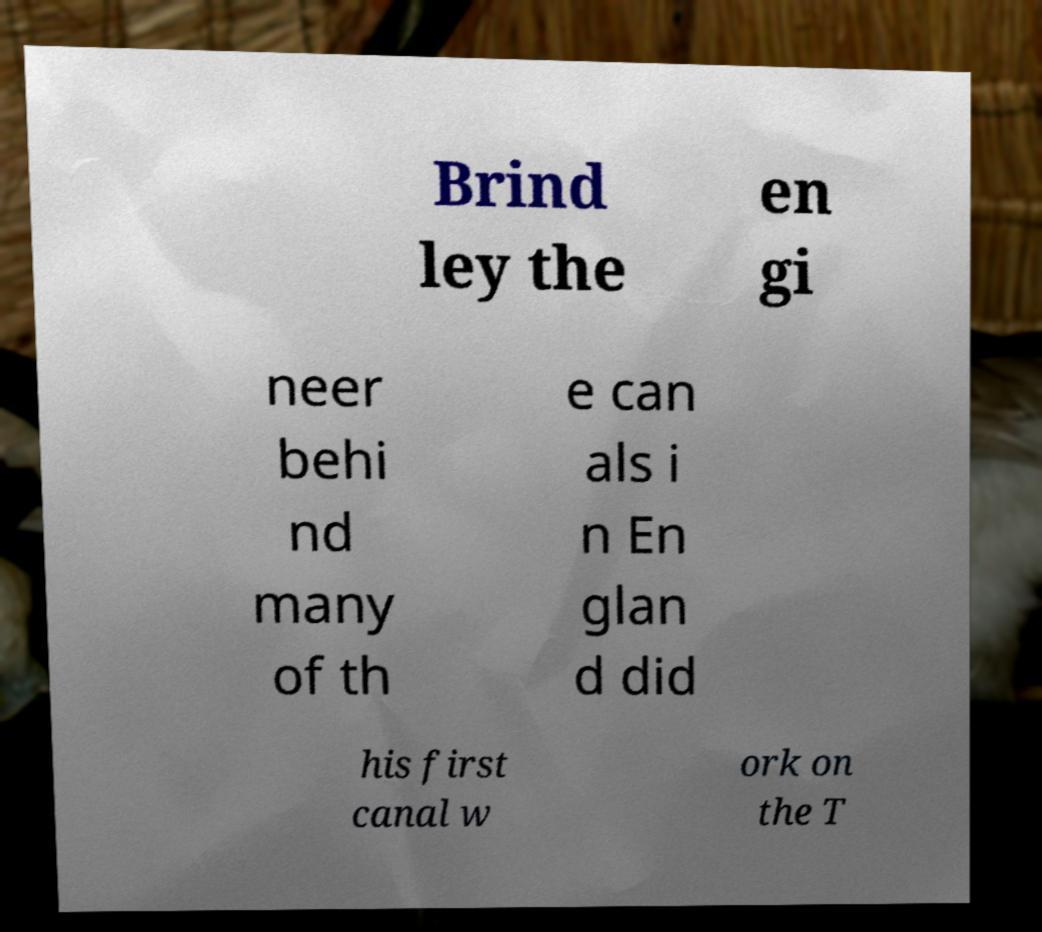Please read and relay the text visible in this image. What does it say? Brind ley the en gi neer behi nd many of th e can als i n En glan d did his first canal w ork on the T 